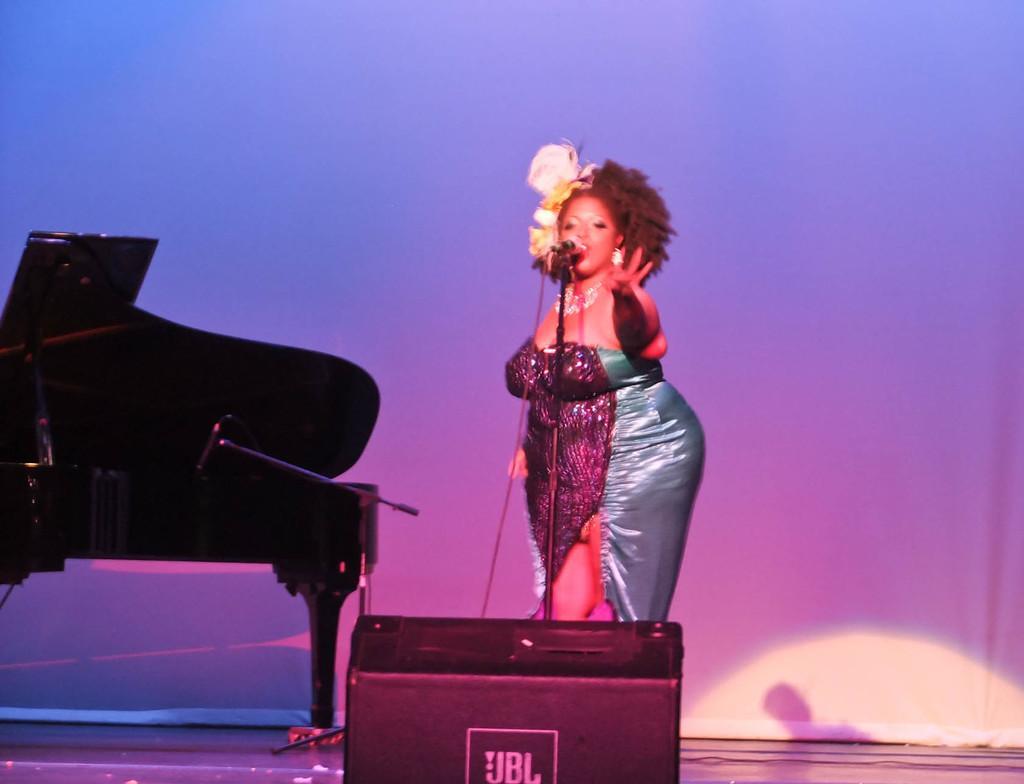Could you give a brief overview of what you see in this image? It is an event,the woman is standing on the stage there is a JBL box in front of her , she is singing a song to her left side there is a big piano in the background there is a violet color wall. 